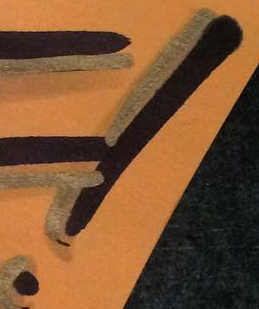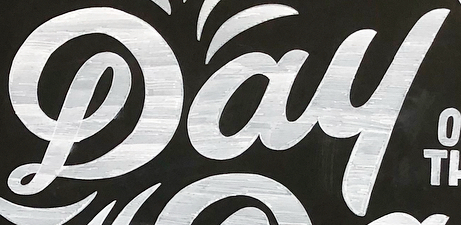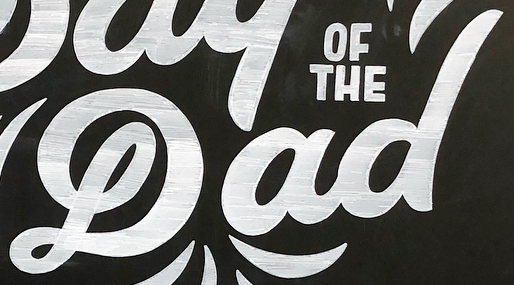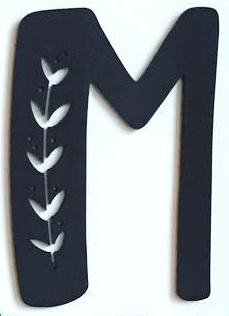Read the text from these images in sequence, separated by a semicolon. !; Dau; Dad; M 